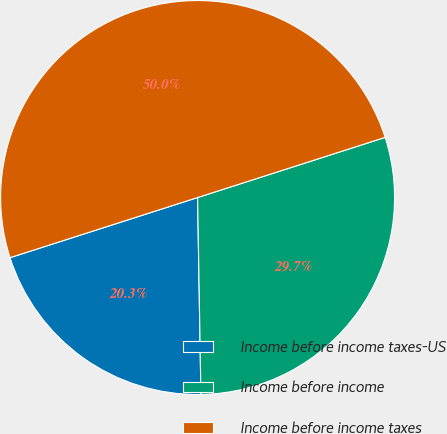Convert chart. <chart><loc_0><loc_0><loc_500><loc_500><pie_chart><fcel>Income before income taxes-US<fcel>Income before income<fcel>Income before income taxes<nl><fcel>20.33%<fcel>29.67%<fcel>50.0%<nl></chart> 